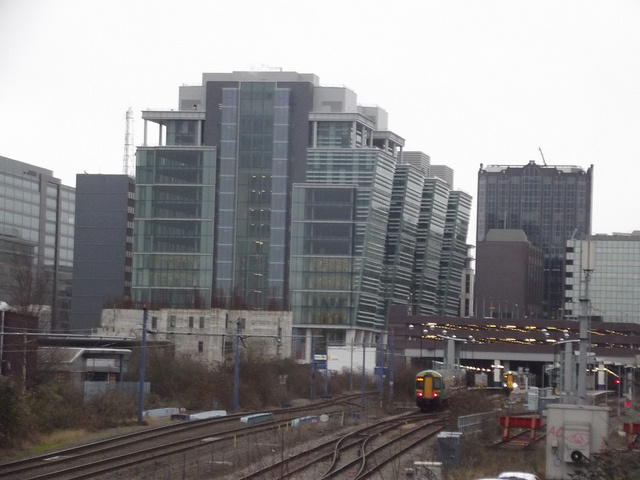Describe the objects in this image and their specific colors. I can see a train in lightgray, black, gray, and olive tones in this image. 